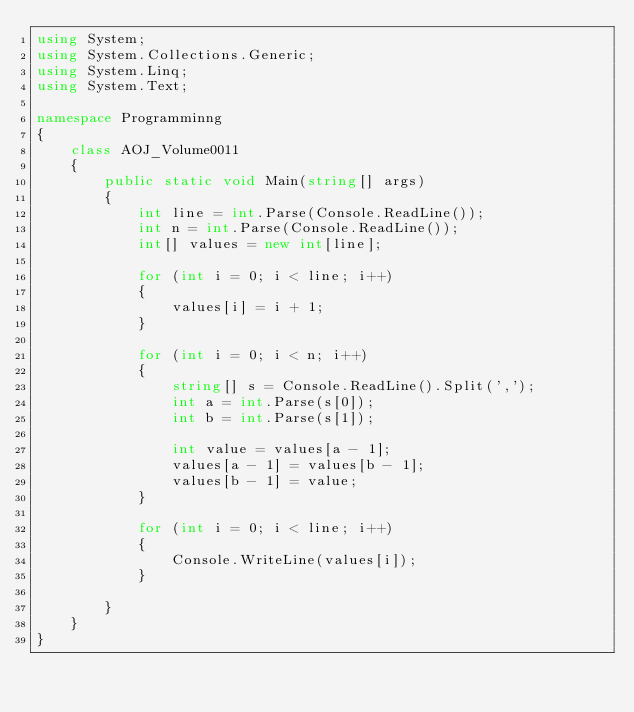Convert code to text. <code><loc_0><loc_0><loc_500><loc_500><_C#_>using System;
using System.Collections.Generic;
using System.Linq;
using System.Text;

namespace Programminng
{
    class AOJ_Volume0011
    {
        public static void Main(string[] args)
        {
            int line = int.Parse(Console.ReadLine());
            int n = int.Parse(Console.ReadLine());
            int[] values = new int[line];

            for (int i = 0; i < line; i++)
            {
                values[i] = i + 1;
            }

            for (int i = 0; i < n; i++)
            {
                string[] s = Console.ReadLine().Split(',');
                int a = int.Parse(s[0]);
                int b = int.Parse(s[1]);

                int value = values[a - 1];
                values[a - 1] = values[b - 1];
                values[b - 1] = value;
            }

            for (int i = 0; i < line; i++)
            {
                Console.WriteLine(values[i]);
            }

        }
    }
}</code> 